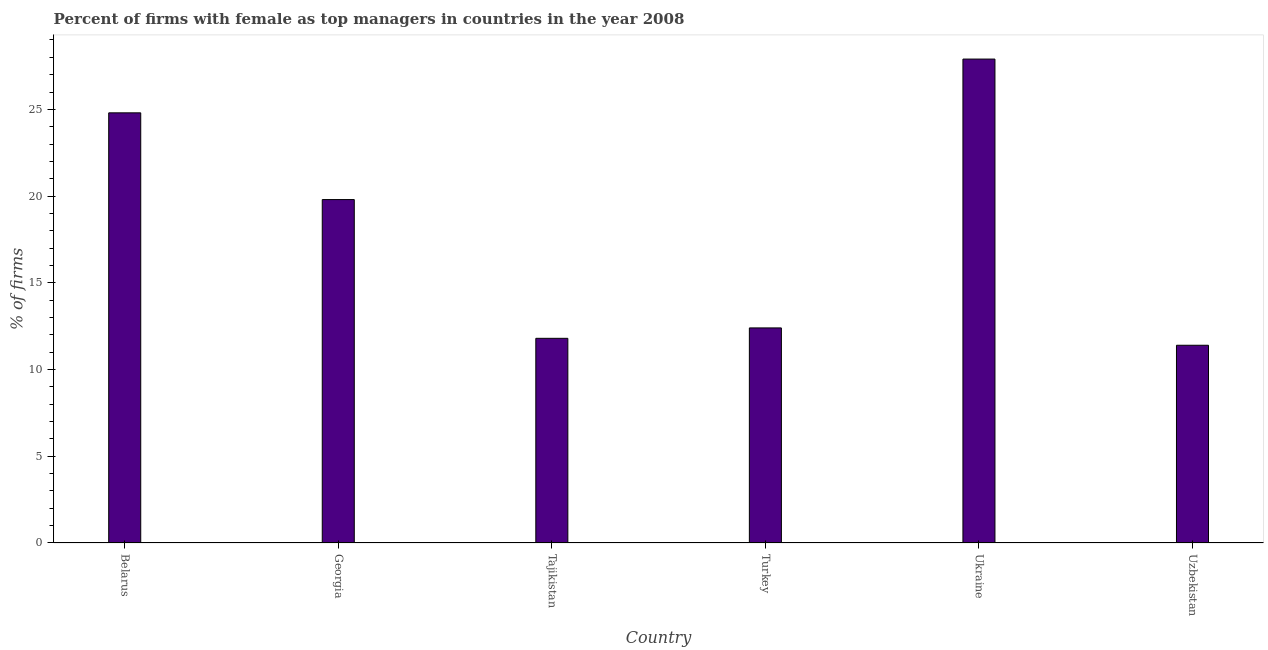Does the graph contain grids?
Ensure brevity in your answer.  No. What is the title of the graph?
Offer a very short reply. Percent of firms with female as top managers in countries in the year 2008. What is the label or title of the Y-axis?
Provide a short and direct response. % of firms. What is the percentage of firms with female as top manager in Turkey?
Offer a terse response. 12.4. Across all countries, what is the maximum percentage of firms with female as top manager?
Offer a terse response. 27.9. In which country was the percentage of firms with female as top manager maximum?
Your answer should be compact. Ukraine. In which country was the percentage of firms with female as top manager minimum?
Your response must be concise. Uzbekistan. What is the sum of the percentage of firms with female as top manager?
Provide a short and direct response. 108.1. What is the average percentage of firms with female as top manager per country?
Offer a terse response. 18.02. In how many countries, is the percentage of firms with female as top manager greater than 24 %?
Provide a short and direct response. 2. What is the ratio of the percentage of firms with female as top manager in Belarus to that in Turkey?
Offer a very short reply. 2. What is the difference between the highest and the second highest percentage of firms with female as top manager?
Ensure brevity in your answer.  3.1. What is the difference between the highest and the lowest percentage of firms with female as top manager?
Your response must be concise. 16.5. How many bars are there?
Your response must be concise. 6. How many countries are there in the graph?
Your response must be concise. 6. What is the difference between two consecutive major ticks on the Y-axis?
Keep it short and to the point. 5. Are the values on the major ticks of Y-axis written in scientific E-notation?
Your answer should be compact. No. What is the % of firms in Belarus?
Ensure brevity in your answer.  24.8. What is the % of firms in Georgia?
Make the answer very short. 19.8. What is the % of firms of Turkey?
Offer a very short reply. 12.4. What is the % of firms in Ukraine?
Give a very brief answer. 27.9. What is the difference between the % of firms in Belarus and Tajikistan?
Your answer should be compact. 13. What is the difference between the % of firms in Belarus and Turkey?
Keep it short and to the point. 12.4. What is the difference between the % of firms in Belarus and Ukraine?
Keep it short and to the point. -3.1. What is the difference between the % of firms in Belarus and Uzbekistan?
Your response must be concise. 13.4. What is the difference between the % of firms in Georgia and Ukraine?
Your answer should be very brief. -8.1. What is the difference between the % of firms in Georgia and Uzbekistan?
Make the answer very short. 8.4. What is the difference between the % of firms in Tajikistan and Ukraine?
Your answer should be compact. -16.1. What is the difference between the % of firms in Turkey and Ukraine?
Keep it short and to the point. -15.5. What is the difference between the % of firms in Ukraine and Uzbekistan?
Offer a terse response. 16.5. What is the ratio of the % of firms in Belarus to that in Georgia?
Provide a short and direct response. 1.25. What is the ratio of the % of firms in Belarus to that in Tajikistan?
Ensure brevity in your answer.  2.1. What is the ratio of the % of firms in Belarus to that in Turkey?
Your response must be concise. 2. What is the ratio of the % of firms in Belarus to that in Ukraine?
Keep it short and to the point. 0.89. What is the ratio of the % of firms in Belarus to that in Uzbekistan?
Your answer should be very brief. 2.17. What is the ratio of the % of firms in Georgia to that in Tajikistan?
Offer a very short reply. 1.68. What is the ratio of the % of firms in Georgia to that in Turkey?
Keep it short and to the point. 1.6. What is the ratio of the % of firms in Georgia to that in Ukraine?
Give a very brief answer. 0.71. What is the ratio of the % of firms in Georgia to that in Uzbekistan?
Your answer should be compact. 1.74. What is the ratio of the % of firms in Tajikistan to that in Ukraine?
Provide a short and direct response. 0.42. What is the ratio of the % of firms in Tajikistan to that in Uzbekistan?
Provide a succinct answer. 1.03. What is the ratio of the % of firms in Turkey to that in Ukraine?
Make the answer very short. 0.44. What is the ratio of the % of firms in Turkey to that in Uzbekistan?
Offer a terse response. 1.09. What is the ratio of the % of firms in Ukraine to that in Uzbekistan?
Your answer should be compact. 2.45. 